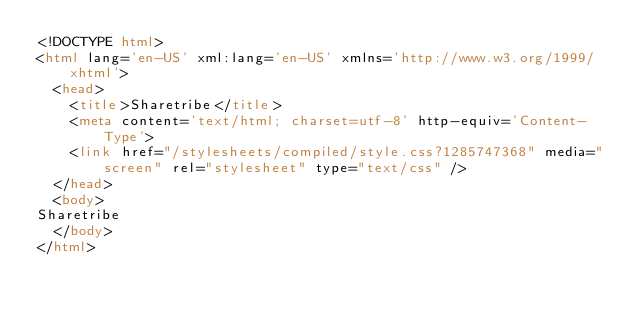Convert code to text. <code><loc_0><loc_0><loc_500><loc_500><_HTML_><!DOCTYPE html> 
<html lang='en-US' xml:lang='en-US' xmlns='http://www.w3.org/1999/xhtml'> 
  <head> 
    <title>Sharetribe</title>
    <meta content='text/html; charset=utf-8' http-equiv='Content-Type'> 
    <link href="/stylesheets/compiled/style.css?1285747368" media="screen" rel="stylesheet" type="text/css" />
  </head> 
  <body> 
Sharetribe
  </body>
</html>
</code> 